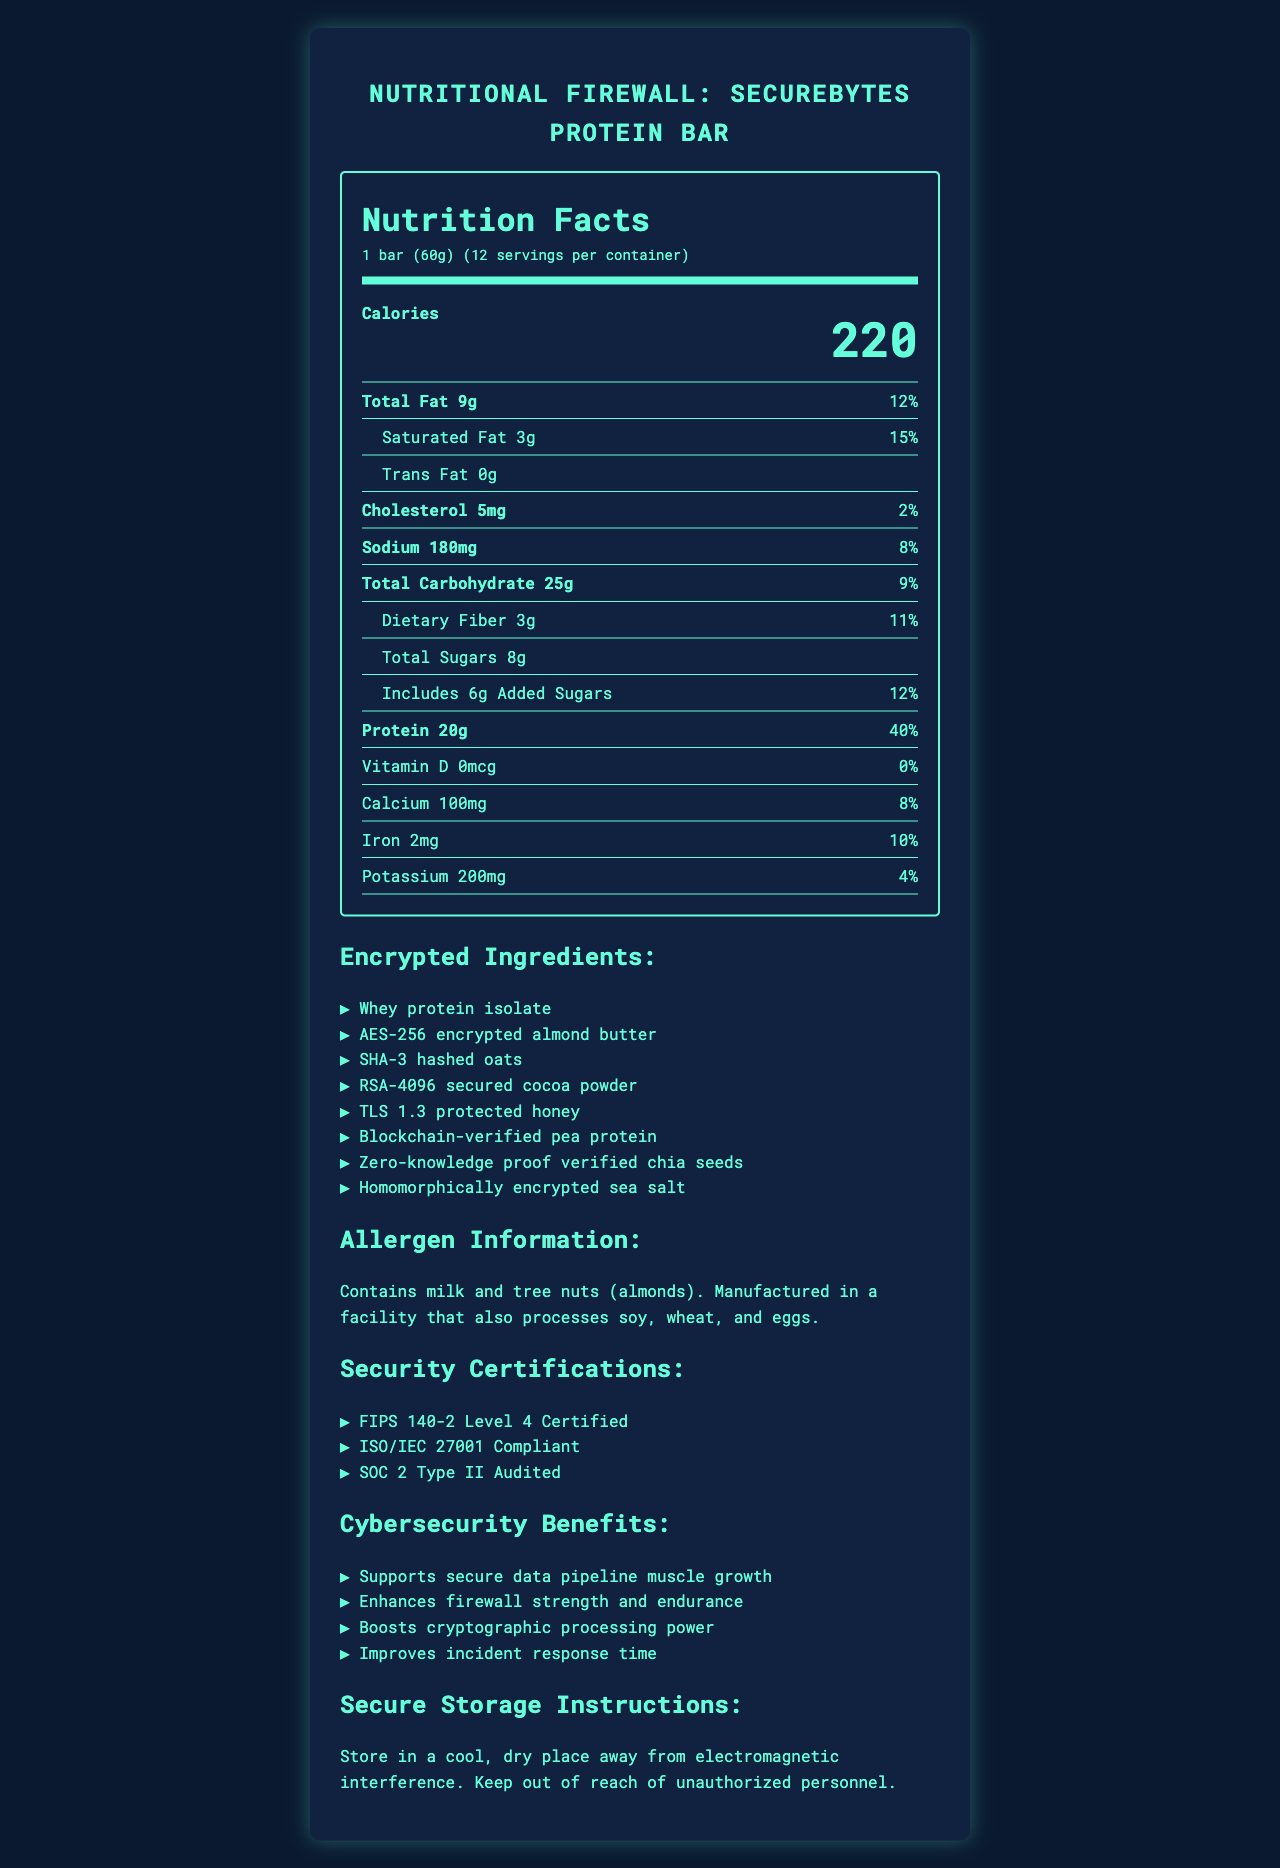What is the serving size of the SecureBytes Protein Bar? The document lists the serving size as "1 bar (60g)" near the top under Serving Info.
Answer: 1 bar (60g) How many calories are there in one serving of the SecureBytes Protein Bar? The nutrition label clearly indicates that there are 220 calories per serving.
Answer: 220 What is the total fat content per serving and its % Daily Value? The document shows that total fat content is 9g with a 12% Daily Value in the nutrient row for Total Fat.
Answer: 9g, 12% List one ingredient used in the SecureBytes Protein Bar. The ingredients section lists several components, and one of them is Whey protein isolate.
Answer: Whey protein isolate How much protein does one serving provide, and what is its % Daily Value? The nutrient row for Protein shows it provides 20g of protein per serving, which is 40% of the Daily Value.
Answer: 20g, 40% What certifications does the SecureBytes Protein Bar have? The certifications section lists these three certifications as the product’s certifications.
Answer: FIPS 140-2 Level 4 Certified, ISO/IEC 27001 Compliant, SOC 2 Type II Audited How should the SecureBytes Protein Bar be stored? The storage instructions suggest keeping the bars in a cool, dry place away from electromagnetic interference and unauthorized personnel.
Answer: Store in a cool, dry place away from electromagnetic interference. Keep out of reach of unauthorized personnel. Does the SecureBytes Protein Bar contain any cholesterol? The document lists 5mg of cholesterol in the nutrient row for Cholesterol.
Answer: Yes What are the cybersecurity benefits of the SecureBytes Protein Bar? The benefits section lists these four points as the cybersecurity benefits.
Answer: Supports secure data pipeline muscle growth, enhances firewall strength and endurance, boosts cryptographic processing power, improves incident response time What is the allergen information for the SecureBytes Protein Bar? The allergen information section states this information.
Answer: Contains milk and tree nuts (almonds). Manufactured in a facility that also processes soy, wheat, and eggs. What is the total carbohydrate content per serving, including dietary fiber and sugars? The document explains that the total carbohydrate content is 25g, with 3g dietary fiber, 8g total sugars, including 6g added sugars.
Answer: Total Carbohydrate: 25g, Dietary Fiber: 3g, Total Sugars: 8g, Includes 6g Added Sugars What is the % Daily Value of iron provided by one serving of the SecureBytes Protein Bar? The nutrient row for Iron indicates it provides 2mg of iron, which is 10% of the Daily Value.
Answer: 10% Which of the following statements is true about the SecureBytes Protein Bar's certifications? A. It is SOC 2 Type I Audited. B. It is ISO/IEC 27001 Compliant. C. It is not certified. The certifications section lists ISO/IEC 27001 Compliant among its certifications.
Answer: B What percentage of the daily value of saturated fat does one serving of the SecureBytes Protein Bar provide? A. 12% B. 15% C. 8% D. 20% The saturated fat content is 3g, which amounts to 15% of the Daily Value, as listed in the document.
Answer: B Is the SecureBytes Protein Bar free of trans fat? The trans fat row indicates 0g, which means the product does not contain any trans fat.
Answer: Yes Summarize the main features of the SecureBytes Protein Bar based on its nutrition label. This detailed summary captures the key nutritional information, ingredients, certifications, benefits, and storage instructions from the document.
Answer: The SecureBytes Protein Bar is a 60g serving product providing 220 calories, with significant amounts of protein (20g, 40% DV) and other nutrients. It includes various encrypted and verified ingredients like AES-256 encrypted almond butter and blockchain-verified pea protein. The product is certified by FIPS 140-2, ISO/IEC 27001, and SOC 2 Type II. It offers benefits like supporting secure data pipeline muscle growth and enhancing firewall endurance. Storage instructions advise keeping it in a cool, dry place away from electromagnetic interference. What is the exact composition of the 'homomorphically encrypted sea salt'? The document lists "homomorphically encrypted sea salt" as an ingredient but does not provide further details on its composition.
Answer: Not enough information 